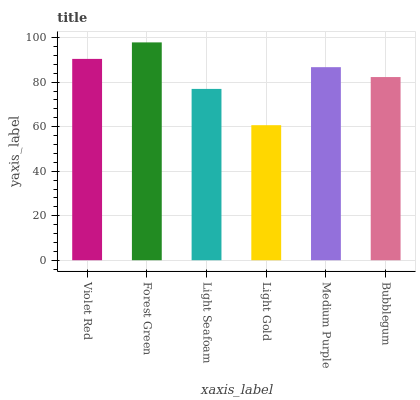Is Light Gold the minimum?
Answer yes or no. Yes. Is Forest Green the maximum?
Answer yes or no. Yes. Is Light Seafoam the minimum?
Answer yes or no. No. Is Light Seafoam the maximum?
Answer yes or no. No. Is Forest Green greater than Light Seafoam?
Answer yes or no. Yes. Is Light Seafoam less than Forest Green?
Answer yes or no. Yes. Is Light Seafoam greater than Forest Green?
Answer yes or no. No. Is Forest Green less than Light Seafoam?
Answer yes or no. No. Is Medium Purple the high median?
Answer yes or no. Yes. Is Bubblegum the low median?
Answer yes or no. Yes. Is Forest Green the high median?
Answer yes or no. No. Is Light Seafoam the low median?
Answer yes or no. No. 